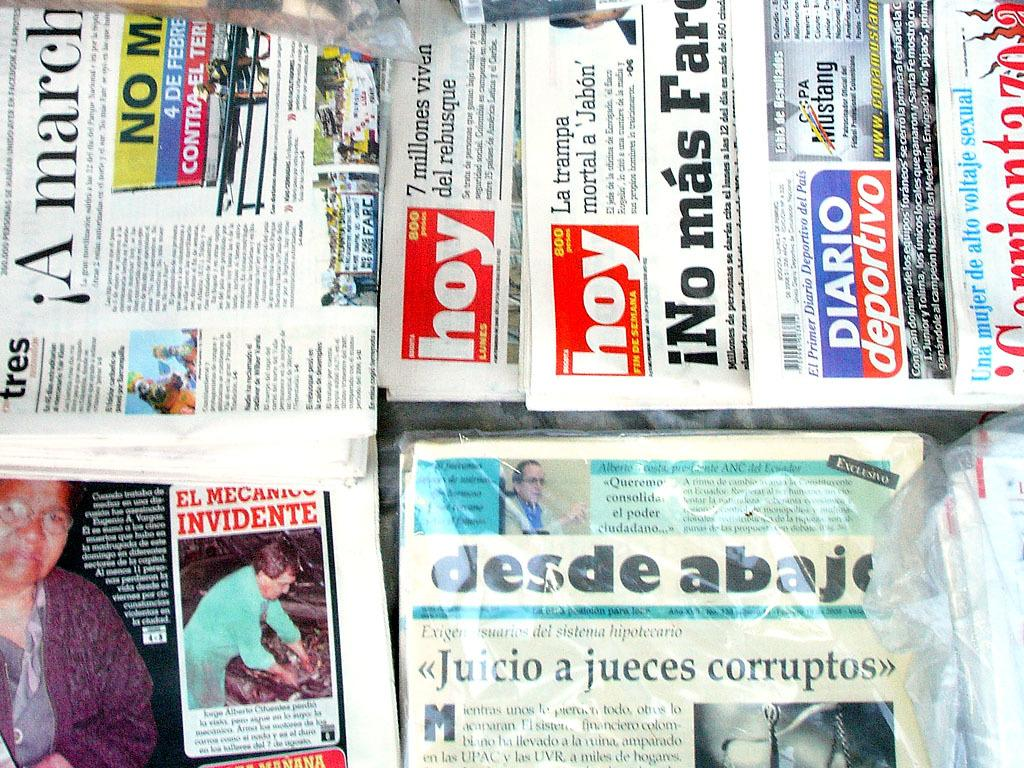Provide a one-sentence caption for the provided image. Several newspapers including hoy and desde abajo are stacked up on top of each other. 